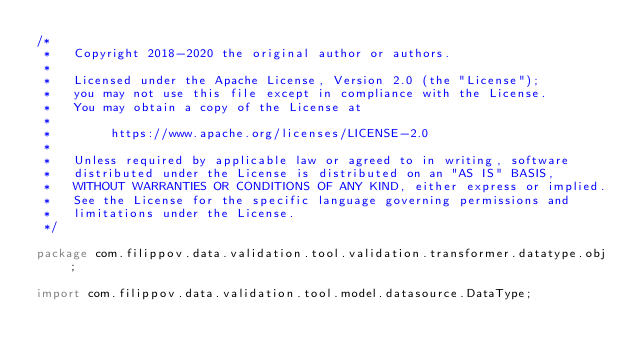Convert code to text. <code><loc_0><loc_0><loc_500><loc_500><_Java_>/*
 *   Copyright 2018-2020 the original author or authors.
 *
 *   Licensed under the Apache License, Version 2.0 (the "License");
 *   you may not use this file except in compliance with the License.
 *   You may obtain a copy of the License at
 *
 *        https://www.apache.org/licenses/LICENSE-2.0
 *
 *   Unless required by applicable law or agreed to in writing, software
 *   distributed under the License is distributed on an "AS IS" BASIS,
 *   WITHOUT WARRANTIES OR CONDITIONS OF ANY KIND, either express or implied.
 *   See the License for the specific language governing permissions and
 *   limitations under the License.
 */

package com.filippov.data.validation.tool.validation.transformer.datatype.obj;

import com.filippov.data.validation.tool.model.datasource.DataType;</code> 